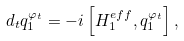<formula> <loc_0><loc_0><loc_500><loc_500>d _ { t } q _ { 1 } ^ { \varphi _ { t } } = - i \left [ H _ { 1 } ^ { e f f } , q _ { 1 } ^ { \varphi _ { t } } \right ] ,</formula> 